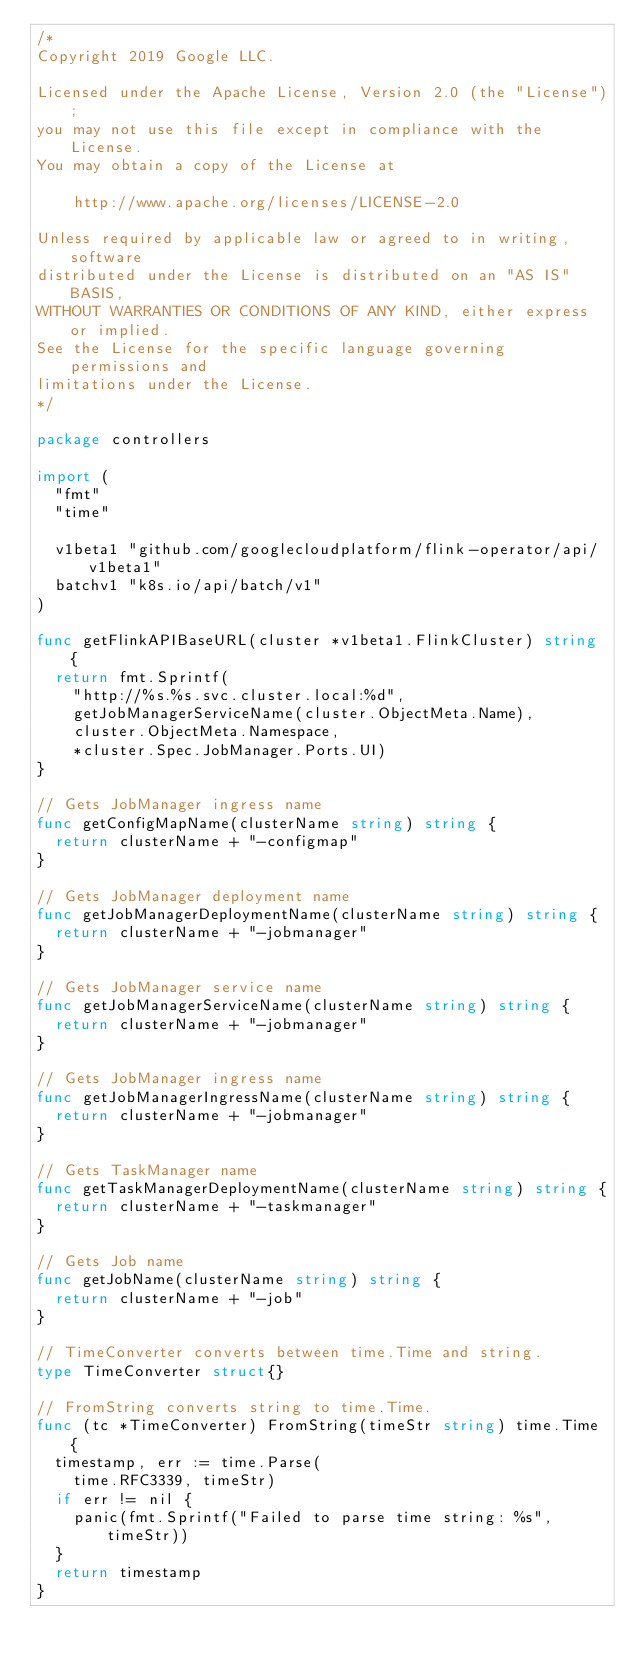Convert code to text. <code><loc_0><loc_0><loc_500><loc_500><_Go_>/*
Copyright 2019 Google LLC.

Licensed under the Apache License, Version 2.0 (the "License");
you may not use this file except in compliance with the License.
You may obtain a copy of the License at

    http://www.apache.org/licenses/LICENSE-2.0

Unless required by applicable law or agreed to in writing, software
distributed under the License is distributed on an "AS IS" BASIS,
WITHOUT WARRANTIES OR CONDITIONS OF ANY KIND, either express or implied.
See the License for the specific language governing permissions and
limitations under the License.
*/

package controllers

import (
	"fmt"
	"time"

	v1beta1 "github.com/googlecloudplatform/flink-operator/api/v1beta1"
	batchv1 "k8s.io/api/batch/v1"
)

func getFlinkAPIBaseURL(cluster *v1beta1.FlinkCluster) string {
	return fmt.Sprintf(
		"http://%s.%s.svc.cluster.local:%d",
		getJobManagerServiceName(cluster.ObjectMeta.Name),
		cluster.ObjectMeta.Namespace,
		*cluster.Spec.JobManager.Ports.UI)
}

// Gets JobManager ingress name
func getConfigMapName(clusterName string) string {
	return clusterName + "-configmap"
}

// Gets JobManager deployment name
func getJobManagerDeploymentName(clusterName string) string {
	return clusterName + "-jobmanager"
}

// Gets JobManager service name
func getJobManagerServiceName(clusterName string) string {
	return clusterName + "-jobmanager"
}

// Gets JobManager ingress name
func getJobManagerIngressName(clusterName string) string {
	return clusterName + "-jobmanager"
}

// Gets TaskManager name
func getTaskManagerDeploymentName(clusterName string) string {
	return clusterName + "-taskmanager"
}

// Gets Job name
func getJobName(clusterName string) string {
	return clusterName + "-job"
}

// TimeConverter converts between time.Time and string.
type TimeConverter struct{}

// FromString converts string to time.Time.
func (tc *TimeConverter) FromString(timeStr string) time.Time {
	timestamp, err := time.Parse(
		time.RFC3339, timeStr)
	if err != nil {
		panic(fmt.Sprintf("Failed to parse time string: %s", timeStr))
	}
	return timestamp
}
</code> 